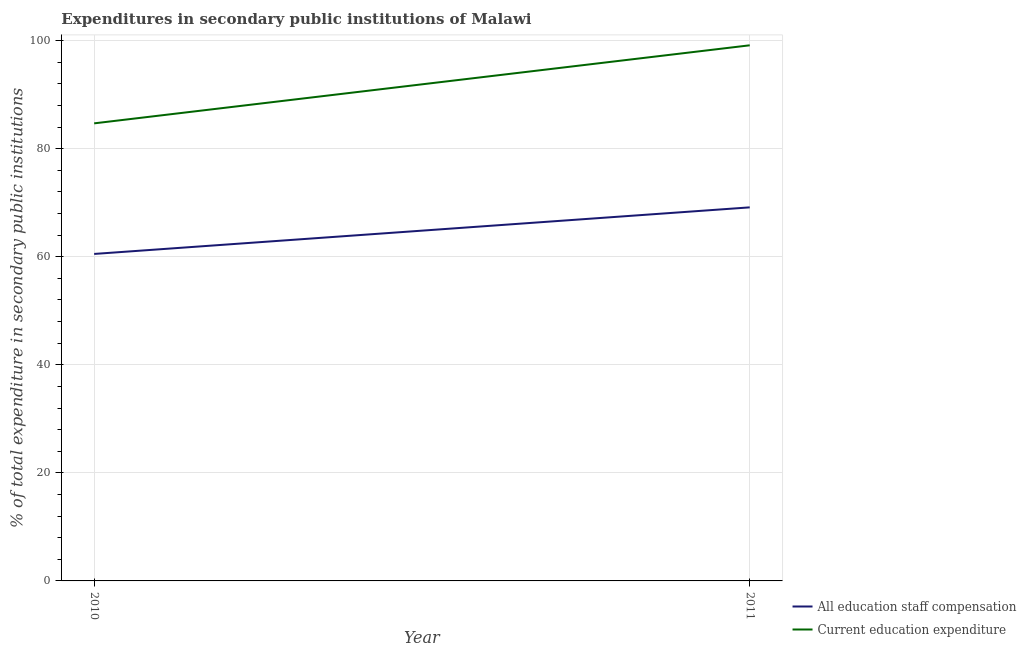How many different coloured lines are there?
Give a very brief answer. 2. Does the line corresponding to expenditure in staff compensation intersect with the line corresponding to expenditure in education?
Offer a terse response. No. Is the number of lines equal to the number of legend labels?
Provide a short and direct response. Yes. What is the expenditure in education in 2011?
Your answer should be very brief. 99.13. Across all years, what is the maximum expenditure in education?
Ensure brevity in your answer.  99.13. Across all years, what is the minimum expenditure in education?
Your answer should be very brief. 84.68. In which year was the expenditure in staff compensation maximum?
Your response must be concise. 2011. In which year was the expenditure in education minimum?
Provide a succinct answer. 2010. What is the total expenditure in staff compensation in the graph?
Keep it short and to the point. 129.65. What is the difference between the expenditure in education in 2010 and that in 2011?
Offer a terse response. -14.45. What is the difference between the expenditure in staff compensation in 2010 and the expenditure in education in 2011?
Provide a succinct answer. -38.61. What is the average expenditure in staff compensation per year?
Keep it short and to the point. 64.82. In the year 2010, what is the difference between the expenditure in education and expenditure in staff compensation?
Offer a very short reply. 24.17. In how many years, is the expenditure in staff compensation greater than 60 %?
Keep it short and to the point. 2. What is the ratio of the expenditure in education in 2010 to that in 2011?
Ensure brevity in your answer.  0.85. Does the expenditure in education monotonically increase over the years?
Your response must be concise. Yes. Is the expenditure in education strictly greater than the expenditure in staff compensation over the years?
Give a very brief answer. Yes. How many lines are there?
Ensure brevity in your answer.  2. What is the difference between two consecutive major ticks on the Y-axis?
Offer a terse response. 20. Does the graph contain any zero values?
Your answer should be compact. No. Does the graph contain grids?
Offer a very short reply. Yes. How many legend labels are there?
Your answer should be compact. 2. How are the legend labels stacked?
Give a very brief answer. Vertical. What is the title of the graph?
Offer a very short reply. Expenditures in secondary public institutions of Malawi. Does "IMF concessional" appear as one of the legend labels in the graph?
Your answer should be compact. No. What is the label or title of the Y-axis?
Keep it short and to the point. % of total expenditure in secondary public institutions. What is the % of total expenditure in secondary public institutions of All education staff compensation in 2010?
Ensure brevity in your answer.  60.51. What is the % of total expenditure in secondary public institutions of Current education expenditure in 2010?
Your answer should be very brief. 84.68. What is the % of total expenditure in secondary public institutions of All education staff compensation in 2011?
Make the answer very short. 69.13. What is the % of total expenditure in secondary public institutions in Current education expenditure in 2011?
Give a very brief answer. 99.13. Across all years, what is the maximum % of total expenditure in secondary public institutions in All education staff compensation?
Ensure brevity in your answer.  69.13. Across all years, what is the maximum % of total expenditure in secondary public institutions in Current education expenditure?
Provide a short and direct response. 99.13. Across all years, what is the minimum % of total expenditure in secondary public institutions of All education staff compensation?
Keep it short and to the point. 60.51. Across all years, what is the minimum % of total expenditure in secondary public institutions of Current education expenditure?
Ensure brevity in your answer.  84.68. What is the total % of total expenditure in secondary public institutions of All education staff compensation in the graph?
Offer a terse response. 129.65. What is the total % of total expenditure in secondary public institutions of Current education expenditure in the graph?
Give a very brief answer. 183.81. What is the difference between the % of total expenditure in secondary public institutions of All education staff compensation in 2010 and that in 2011?
Provide a succinct answer. -8.62. What is the difference between the % of total expenditure in secondary public institutions in Current education expenditure in 2010 and that in 2011?
Your answer should be compact. -14.45. What is the difference between the % of total expenditure in secondary public institutions of All education staff compensation in 2010 and the % of total expenditure in secondary public institutions of Current education expenditure in 2011?
Offer a terse response. -38.61. What is the average % of total expenditure in secondary public institutions of All education staff compensation per year?
Your answer should be compact. 64.82. What is the average % of total expenditure in secondary public institutions in Current education expenditure per year?
Your answer should be very brief. 91.9. In the year 2010, what is the difference between the % of total expenditure in secondary public institutions of All education staff compensation and % of total expenditure in secondary public institutions of Current education expenditure?
Your answer should be compact. -24.17. In the year 2011, what is the difference between the % of total expenditure in secondary public institutions of All education staff compensation and % of total expenditure in secondary public institutions of Current education expenditure?
Your answer should be compact. -29.99. What is the ratio of the % of total expenditure in secondary public institutions in All education staff compensation in 2010 to that in 2011?
Make the answer very short. 0.88. What is the ratio of the % of total expenditure in secondary public institutions in Current education expenditure in 2010 to that in 2011?
Ensure brevity in your answer.  0.85. What is the difference between the highest and the second highest % of total expenditure in secondary public institutions in All education staff compensation?
Offer a terse response. 8.62. What is the difference between the highest and the second highest % of total expenditure in secondary public institutions in Current education expenditure?
Ensure brevity in your answer.  14.45. What is the difference between the highest and the lowest % of total expenditure in secondary public institutions of All education staff compensation?
Your answer should be compact. 8.62. What is the difference between the highest and the lowest % of total expenditure in secondary public institutions of Current education expenditure?
Provide a short and direct response. 14.45. 